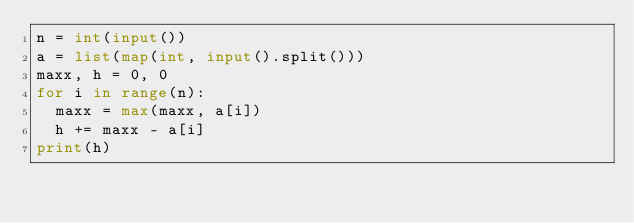Convert code to text. <code><loc_0><loc_0><loc_500><loc_500><_Python_>n = int(input())
a = list(map(int, input().split()))
maxx, h = 0, 0
for i in range(n):
	maxx = max(maxx, a[i])
	h += maxx - a[i]
print(h)</code> 